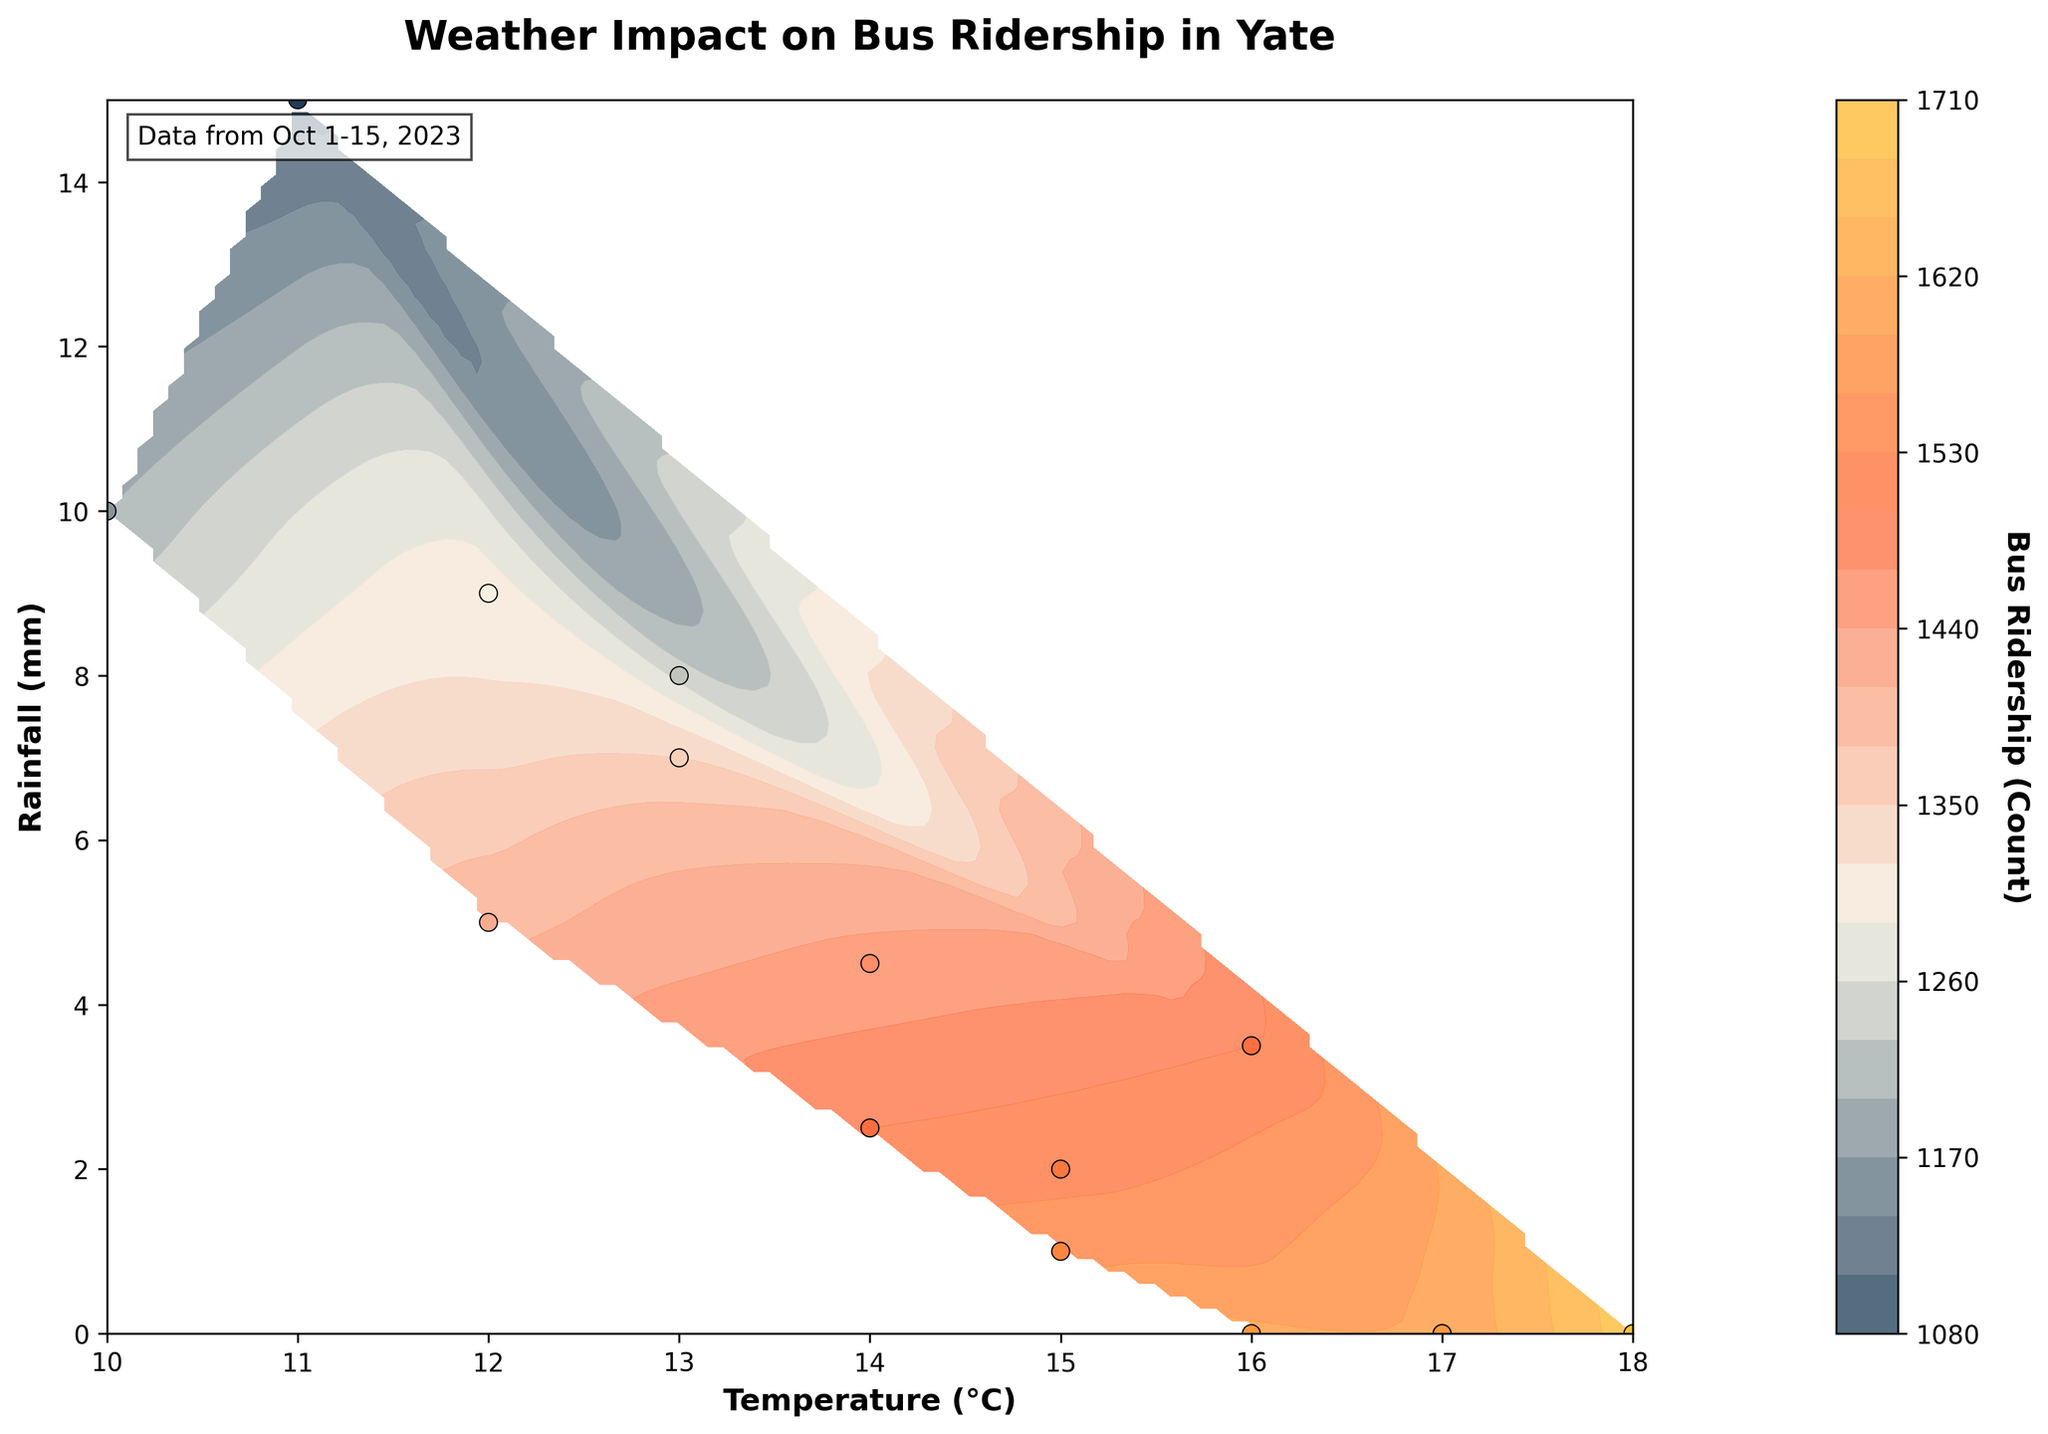What is the title of the plot? The title is usually displayed at the top of the plot in bold, providing context about what the data visualizations represent.
Answer: Weather Impact on Bus Ridership in Yate What do the x and y axes represent? The axes usually have labels that describe what they represent. Here, the x-axis label is 'Temperature (°C)', and the y-axis label is 'Rainfall (mm)'.
Answer: Temperature (°C) and Rainfall (mm) What is the colorbar used for in the plot? The colorbar provides a scale for understanding the range of the data values (Bus Ridership) represented by different colors in the contour plot.
Answer: Bus Ridership (Count) Is there a visible trend between rainfall and bus ridership? By observing the contour lines and color gradients related to rainfall on the y-axis, a trend can be identified. Here, darker colors generally appear as rainfall increases, indicating lower ridership.
Answer: Ridership generally decreases as rainfall increases Which day had the highest bus ridership and what were the temperature and rainfall on that day? The highest ridership data point appears at the maximum value on the z-axis. The corresponding x and y coordinates give the temperature and rainfall on that day.
Answer: October 10, Temperature: 18°C, Rainfall: 0.0mm On days with temperatures above 16°C, how does bus ridership change as rainfall increases? Compare contour and scatter plot points for temperatures above 16°C and observe how the color gradients (ridership values) change with increasing rainfall. Ridership decreases as rainfall increases.
Answer: Ridership decreases with increasing rainfall Which combination of conditions seems to result in the lowest bus ridership? Identify the region on the contour plot with the darkest colors (lowest ridership) and note the corresponding temperature and rainfall values.
Answer: Low Temperature and High Rainfall Compare bus ridership on October 4th and October 10th. Which day had higher ridership, and by how much? Refer to the scatter plot points and find the ridership for both days, then calculate the difference. October 10th: 1700; October 4th: 1200; Difference: 1700 - 1200
Answer: October 10th, by 500 What range of temperatures tends to correlate with the highest bus ridership? Look for the lightest color gradients and highest contour levels on the x-axis (temperature) to determine the temperature range with high ridership.
Answer: 16°C to 18°C How does wind speed correlate with days of highest and lowest ridership? Examine the data points and assess the wind speed values for the highest (October 10th, 1700 ridership) and lowest (October 8th, 1100 ridership) ridership cases.
Answer: Higher ridership (10 km/h), Lower ridership (25 km/h) 